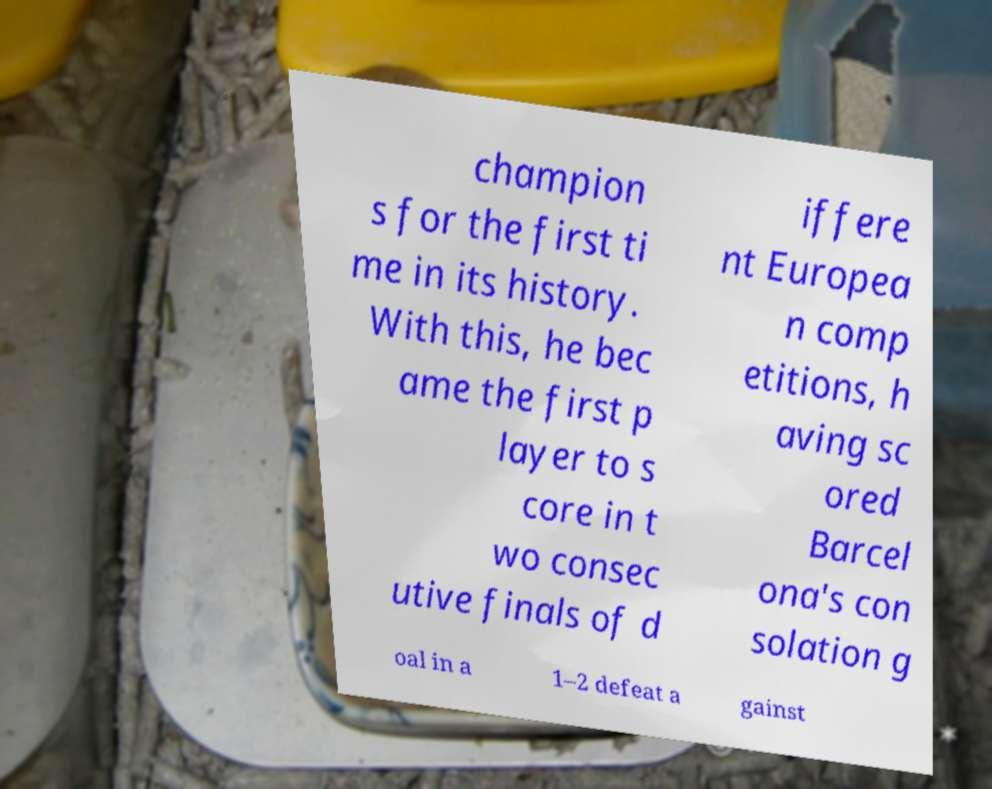Please read and relay the text visible in this image. What does it say? champion s for the first ti me in its history. With this, he bec ame the first p layer to s core in t wo consec utive finals of d iffere nt Europea n comp etitions, h aving sc ored Barcel ona's con solation g oal in a 1–2 defeat a gainst 